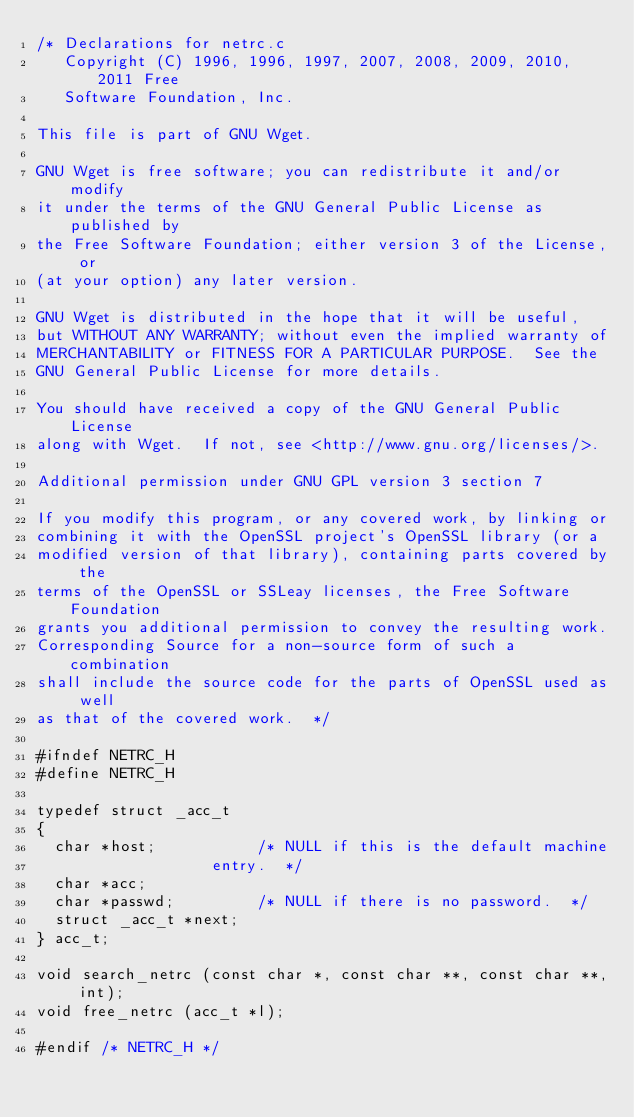Convert code to text. <code><loc_0><loc_0><loc_500><loc_500><_C_>/* Declarations for netrc.c
   Copyright (C) 1996, 1996, 1997, 2007, 2008, 2009, 2010, 2011 Free
   Software Foundation, Inc.

This file is part of GNU Wget.

GNU Wget is free software; you can redistribute it and/or modify
it under the terms of the GNU General Public License as published by
the Free Software Foundation; either version 3 of the License, or
(at your option) any later version.

GNU Wget is distributed in the hope that it will be useful,
but WITHOUT ANY WARRANTY; without even the implied warranty of
MERCHANTABILITY or FITNESS FOR A PARTICULAR PURPOSE.  See the
GNU General Public License for more details.

You should have received a copy of the GNU General Public License
along with Wget.  If not, see <http://www.gnu.org/licenses/>.

Additional permission under GNU GPL version 3 section 7

If you modify this program, or any covered work, by linking or
combining it with the OpenSSL project's OpenSSL library (or a
modified version of that library), containing parts covered by the
terms of the OpenSSL or SSLeay licenses, the Free Software Foundation
grants you additional permission to convey the resulting work.
Corresponding Source for a non-source form of such a combination
shall include the source code for the parts of OpenSSL used as well
as that of the covered work.  */

#ifndef NETRC_H
#define NETRC_H

typedef struct _acc_t
{
  char *host;			/* NULL if this is the default machine
				   entry.  */
  char *acc;
  char *passwd;			/* NULL if there is no password.  */
  struct _acc_t *next;
} acc_t;

void search_netrc (const char *, const char **, const char **, int);
void free_netrc (acc_t *l);

#endif /* NETRC_H */
</code> 